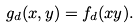Convert formula to latex. <formula><loc_0><loc_0><loc_500><loc_500>g _ { d } ( x , y ) = f _ { d } ( x y ) .</formula> 